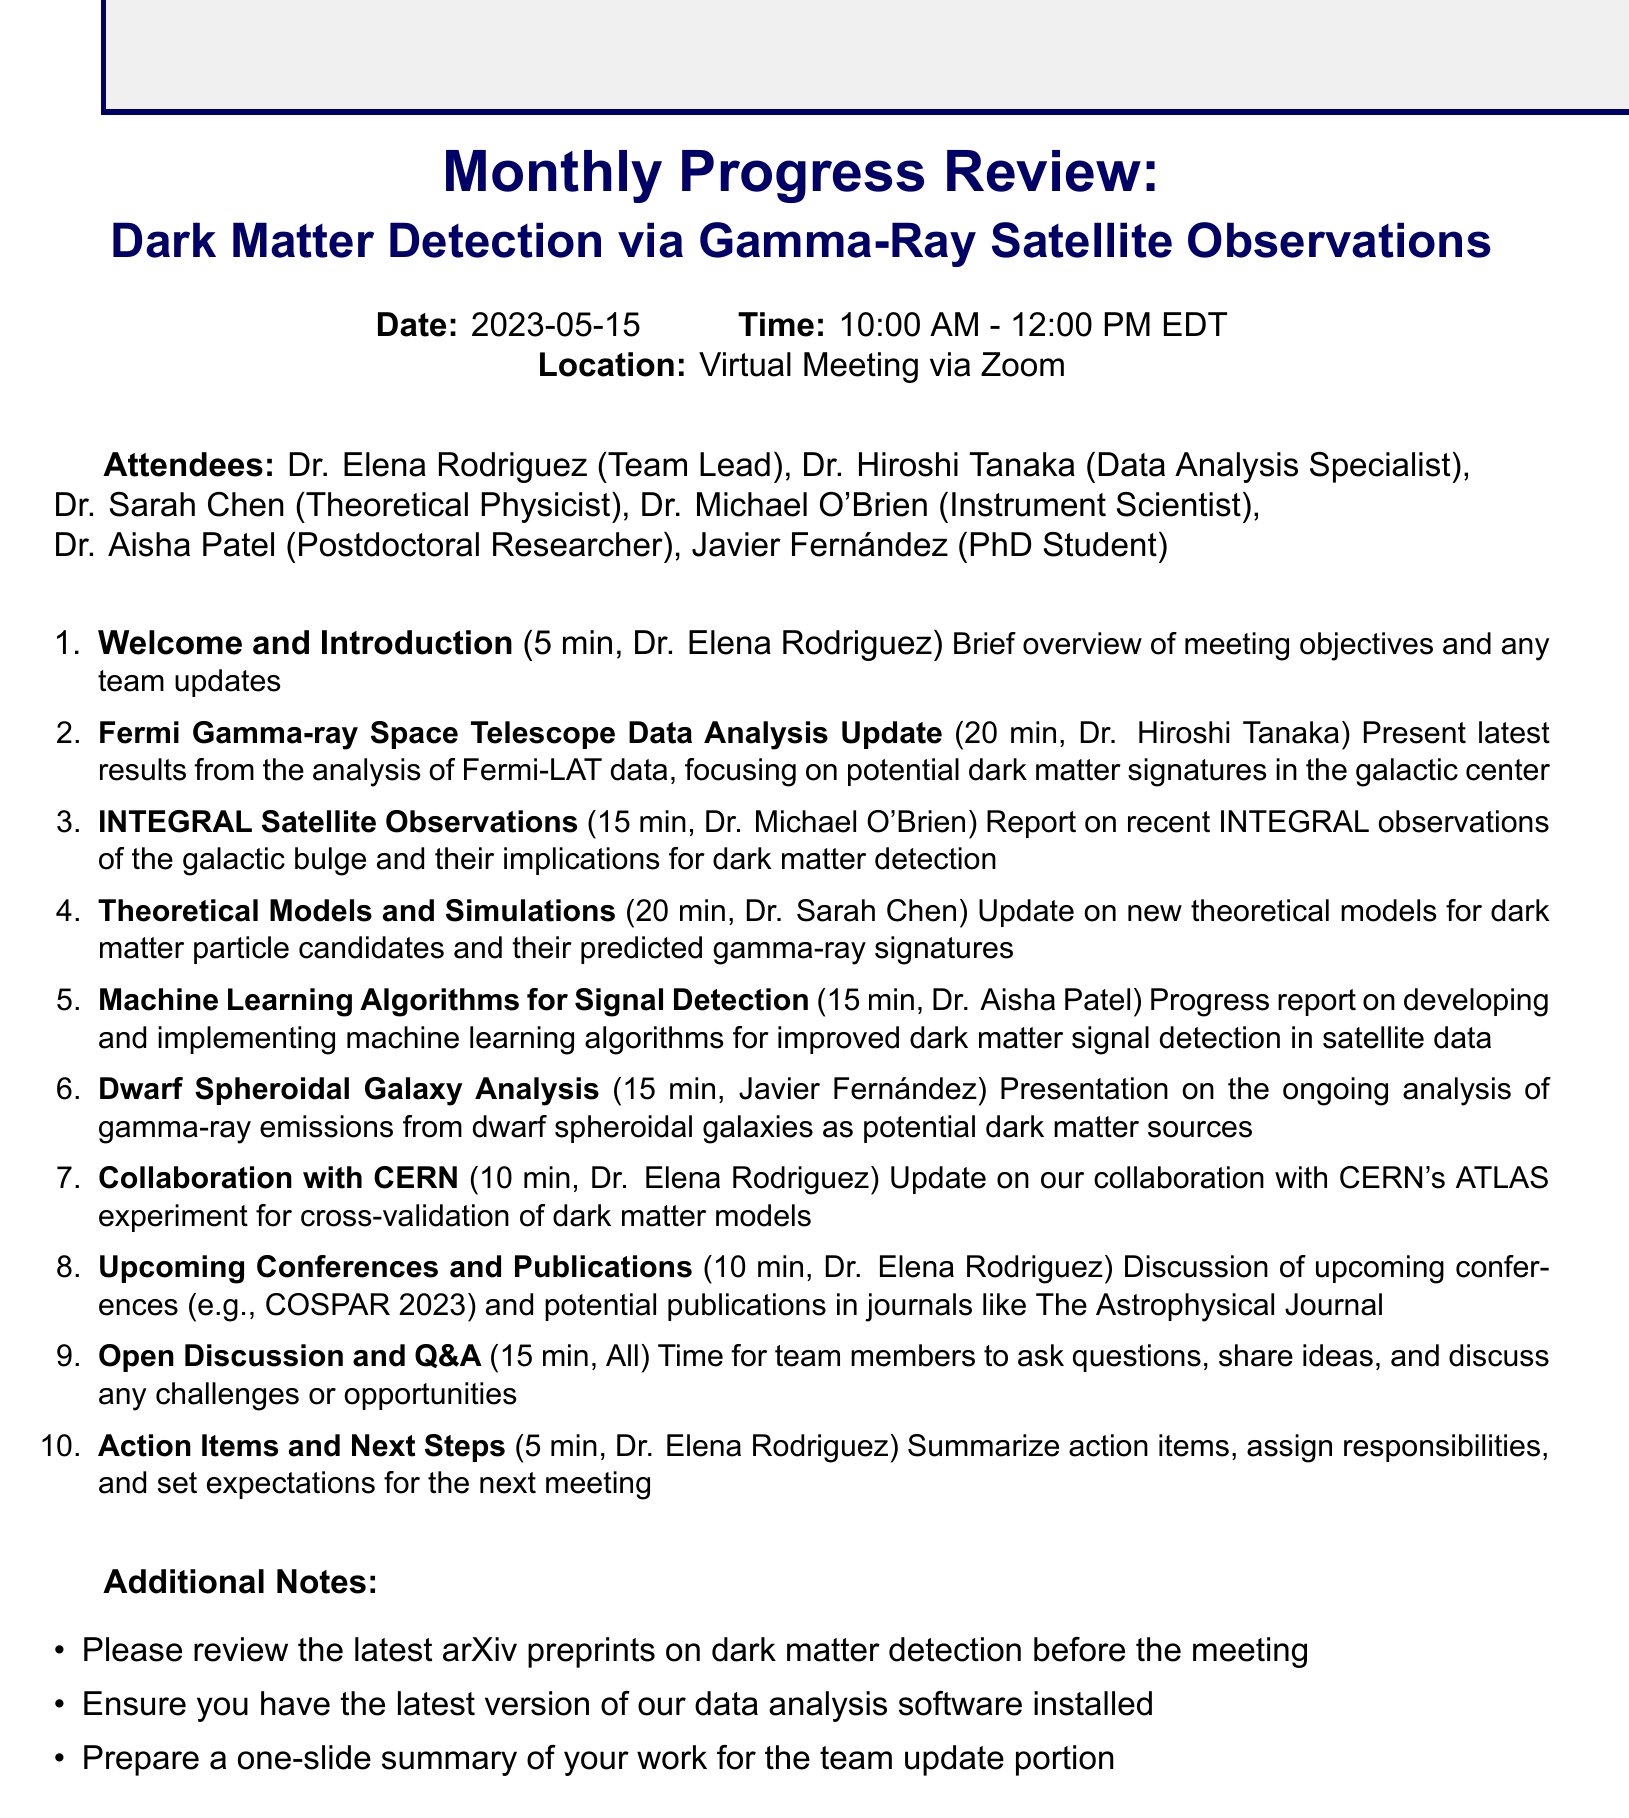What is the meeting date? The meeting date is specified in the document as May 15, 2023.
Answer: May 15, 2023 Who is the presenter for item 2? The document specifies Dr. Hiroshi Tanaka as the presenter for the second agenda item.
Answer: Dr. Hiroshi Tanaka How long is the discussion about collaboration with CERN? The duration for the collaboration with CERN is indicated in the agenda as 10 minutes.
Answer: 10 minutes What is the main focus of Dr. Hirosi Tanaka's presentation? The details in the document mention that Dr. Tanaka's presentation focuses on potential dark matter signatures in the galactic center.
Answer: Potential dark matter signatures in the galactic center How many attendees are listed in the document? The document lists six attendees, each with their respective titles and roles.
Answer: Six attendees What is the total duration of the meeting? The total duration is calculated by adding the durations of all agenda items and is explicitly mentioned as from 10:00 AM to 12:00 PM.
Answer: Two hours What is the title of the meeting? The title is specified prominently in the document and is related to dark matter detection and gamma-ray observations.
Answer: Monthly Progress Review: Dark Matter Detection via Gamma-Ray Satellite Observations What should team members prepare for the meeting? The additional notes section states that team members should prepare a one-slide summary of their work for the team update portion.
Answer: A one-slide summary of your work What is the purpose of the open discussion session? The document states that the open discussion session is meant for team members to ask questions and share ideas.
Answer: To ask questions and share ideas 